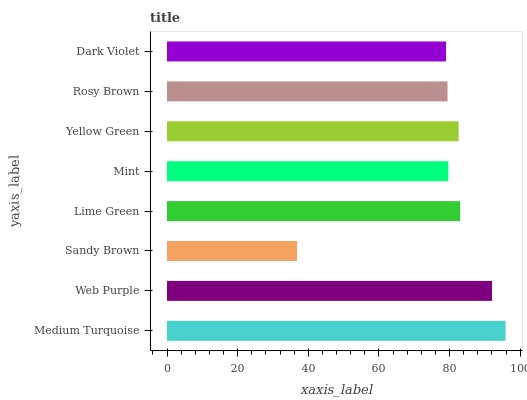Is Sandy Brown the minimum?
Answer yes or no. Yes. Is Medium Turquoise the maximum?
Answer yes or no. Yes. Is Web Purple the minimum?
Answer yes or no. No. Is Web Purple the maximum?
Answer yes or no. No. Is Medium Turquoise greater than Web Purple?
Answer yes or no. Yes. Is Web Purple less than Medium Turquoise?
Answer yes or no. Yes. Is Web Purple greater than Medium Turquoise?
Answer yes or no. No. Is Medium Turquoise less than Web Purple?
Answer yes or no. No. Is Yellow Green the high median?
Answer yes or no. Yes. Is Mint the low median?
Answer yes or no. Yes. Is Sandy Brown the high median?
Answer yes or no. No. Is Yellow Green the low median?
Answer yes or no. No. 